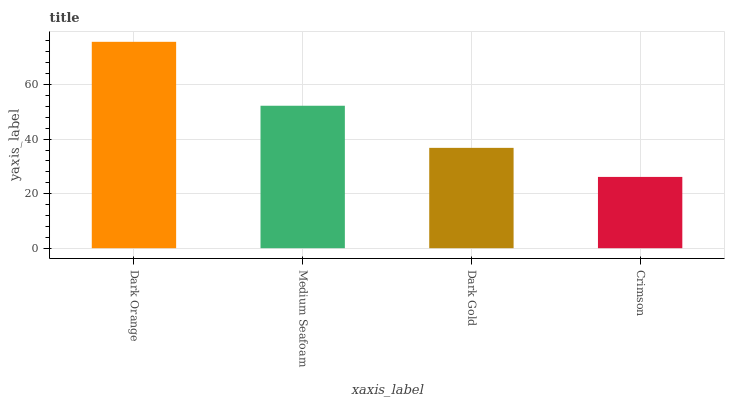Is Crimson the minimum?
Answer yes or no. Yes. Is Dark Orange the maximum?
Answer yes or no. Yes. Is Medium Seafoam the minimum?
Answer yes or no. No. Is Medium Seafoam the maximum?
Answer yes or no. No. Is Dark Orange greater than Medium Seafoam?
Answer yes or no. Yes. Is Medium Seafoam less than Dark Orange?
Answer yes or no. Yes. Is Medium Seafoam greater than Dark Orange?
Answer yes or no. No. Is Dark Orange less than Medium Seafoam?
Answer yes or no. No. Is Medium Seafoam the high median?
Answer yes or no. Yes. Is Dark Gold the low median?
Answer yes or no. Yes. Is Dark Gold the high median?
Answer yes or no. No. Is Dark Orange the low median?
Answer yes or no. No. 